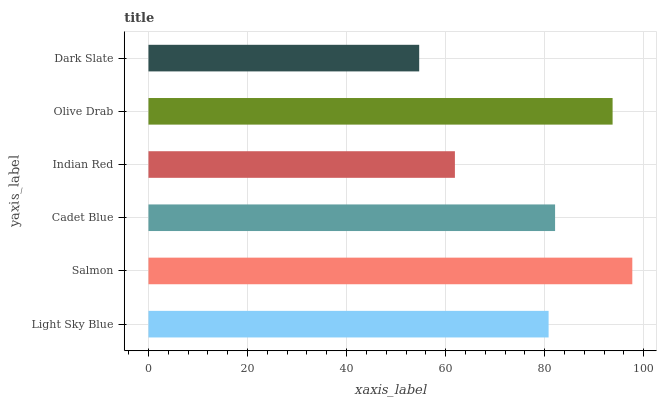Is Dark Slate the minimum?
Answer yes or no. Yes. Is Salmon the maximum?
Answer yes or no. Yes. Is Cadet Blue the minimum?
Answer yes or no. No. Is Cadet Blue the maximum?
Answer yes or no. No. Is Salmon greater than Cadet Blue?
Answer yes or no. Yes. Is Cadet Blue less than Salmon?
Answer yes or no. Yes. Is Cadet Blue greater than Salmon?
Answer yes or no. No. Is Salmon less than Cadet Blue?
Answer yes or no. No. Is Cadet Blue the high median?
Answer yes or no. Yes. Is Light Sky Blue the low median?
Answer yes or no. Yes. Is Indian Red the high median?
Answer yes or no. No. Is Cadet Blue the low median?
Answer yes or no. No. 